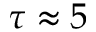Convert formula to latex. <formula><loc_0><loc_0><loc_500><loc_500>\tau \approx 5</formula> 